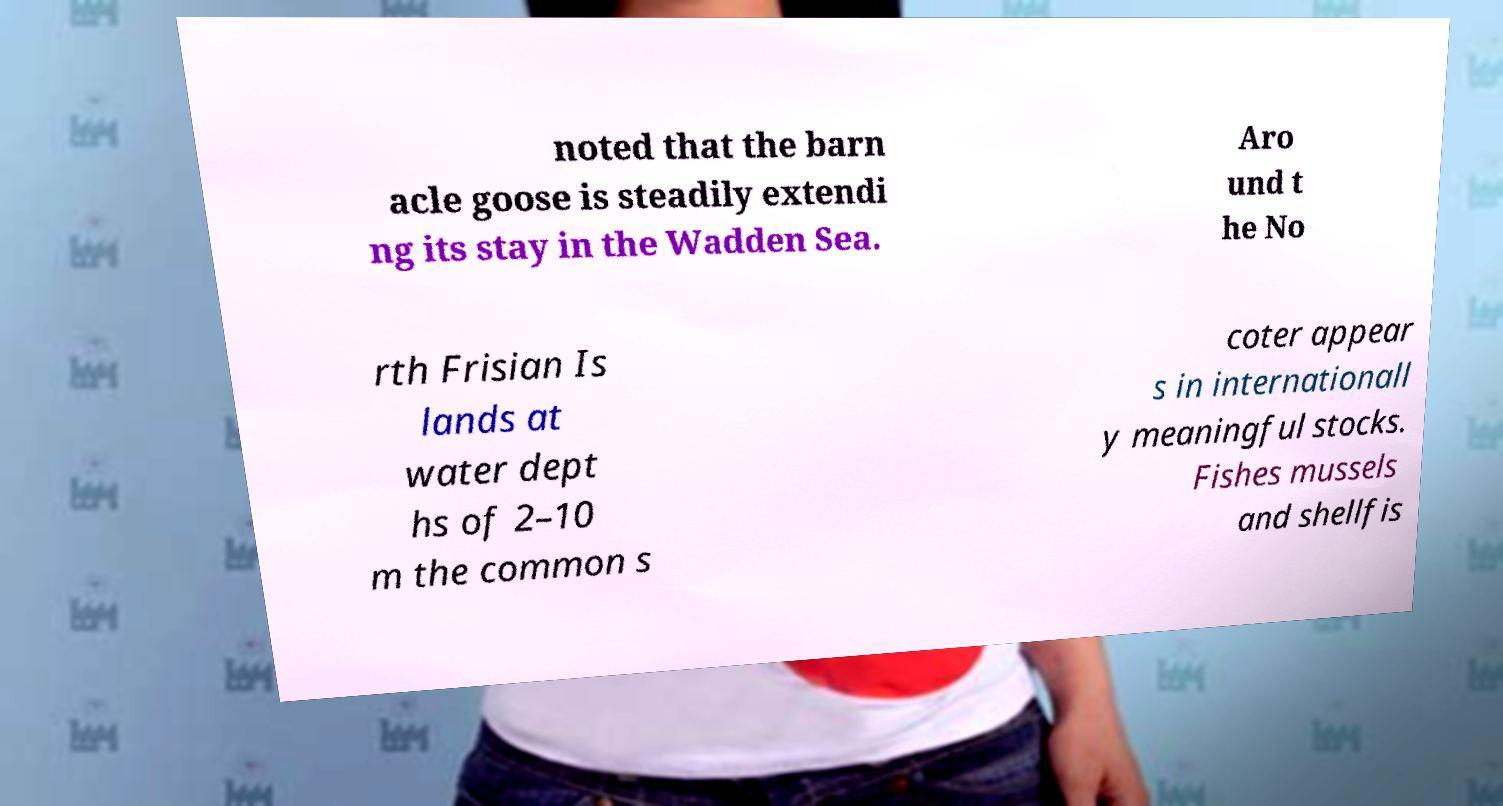What messages or text are displayed in this image? I need them in a readable, typed format. noted that the barn acle goose is steadily extendi ng its stay in the Wadden Sea. Aro und t he No rth Frisian Is lands at water dept hs of 2–10 m the common s coter appear s in internationall y meaningful stocks. Fishes mussels and shellfis 